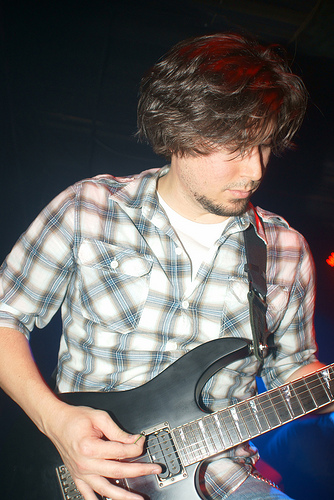<image>
Is there a ha to the left of the leftarm? No. The ha is not to the left of the leftarm. From this viewpoint, they have a different horizontal relationship. 